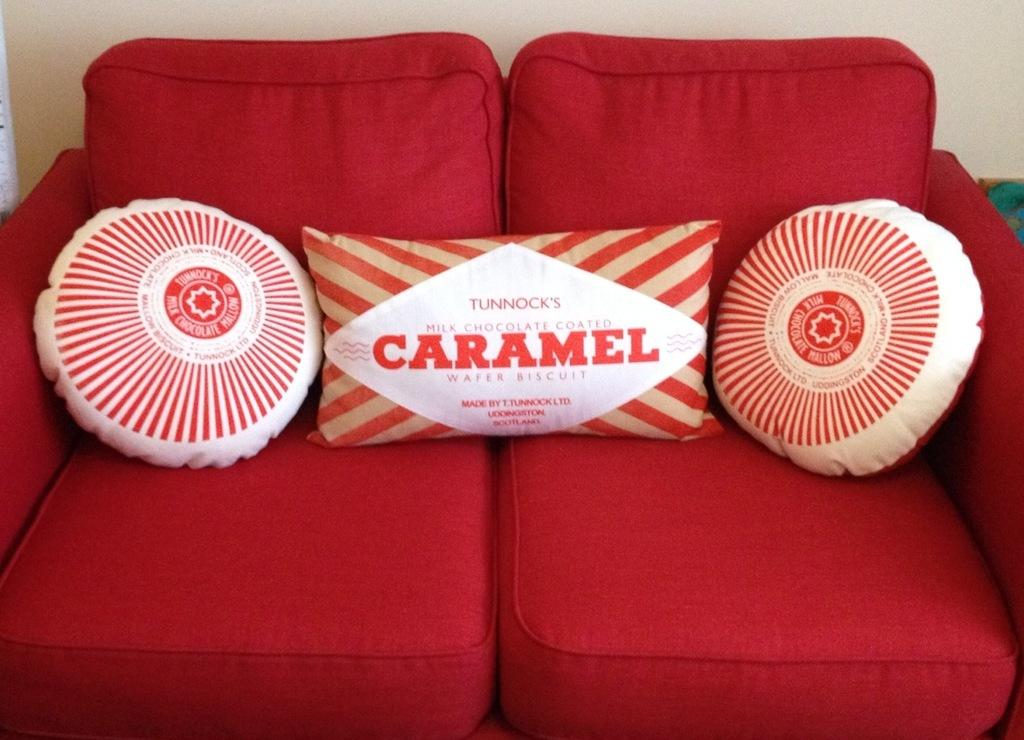What color is the sofa in the image? The sofa in the image is red. How many pillows are on the sofa? There are three pillows on the sofa. What is behind the sofa in the image? There is a wall behind the sofa. What type of polish is being applied to the sofa in the image? There is no indication in the image that any polish is being applied to the sofa. 